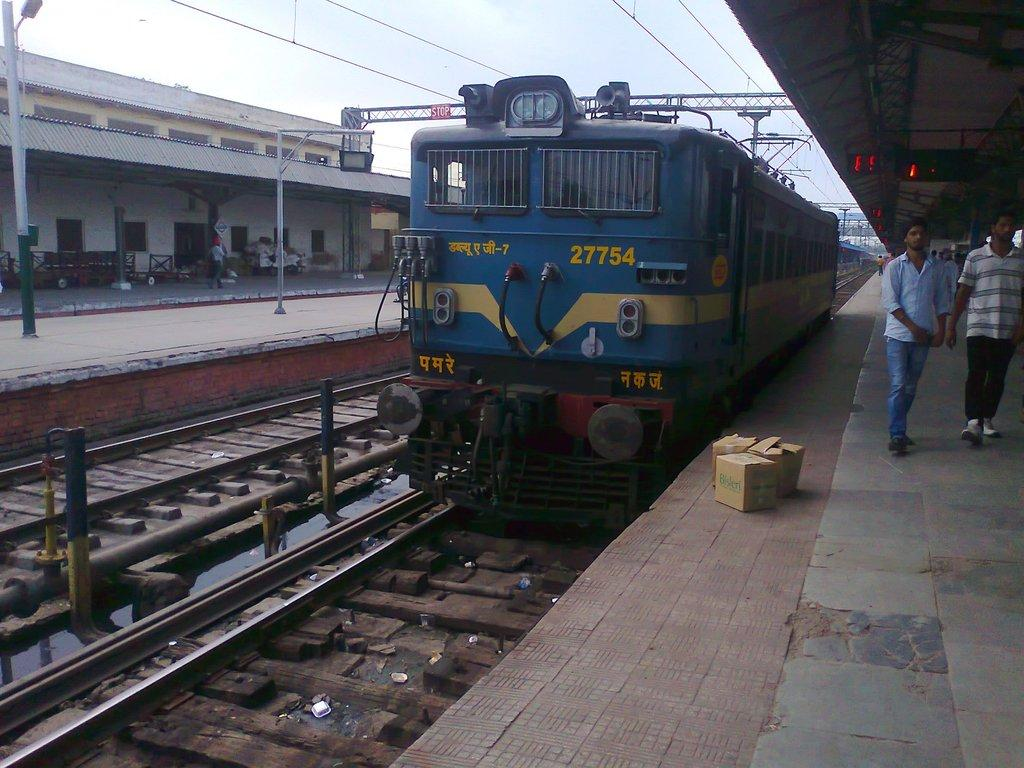What type of transportation infrastructure is shown in the image? There is a railway station in the image. What is the primary feature of a railway station? Train tracks are present in the image. Is there any train activity visible in the image? Yes, there is a train on one of the tracks. Are there any people present in the image? Yes, two people are walking on the right side of the image. Where is the nearest leather store to the railway station in the image? There is no information about a leather store in the image or its vicinity. Can you see any animals at the zoo in the image? There is no zoo present in the image. 